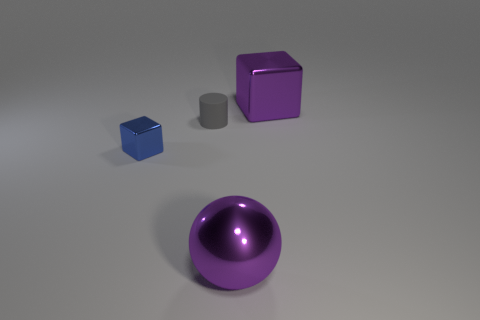There is a tiny blue block; are there any gray cylinders in front of it?
Keep it short and to the point. No. How many things are large things behind the cylinder or blue rubber cylinders?
Offer a terse response. 1. How many blue objects are large rubber balls or small metallic blocks?
Give a very brief answer. 1. How many other things are there of the same color as the large shiny block?
Your answer should be compact. 1. Are there fewer gray rubber cylinders in front of the small gray rubber cylinder than metal cylinders?
Offer a very short reply. No. There is a large metallic object in front of the big purple metallic thing right of the large thing that is to the left of the large metal block; what color is it?
Offer a very short reply. Purple. Are there any other things that are the same material as the tiny gray thing?
Your answer should be compact. No. Are there fewer metallic objects that are behind the rubber object than things that are to the right of the tiny blue metallic thing?
Give a very brief answer. Yes. There is a object that is in front of the small rubber object and right of the tiny blue metal block; what shape is it?
Keep it short and to the point. Sphere. What is the size of the sphere that is made of the same material as the small blue block?
Your response must be concise. Large. 